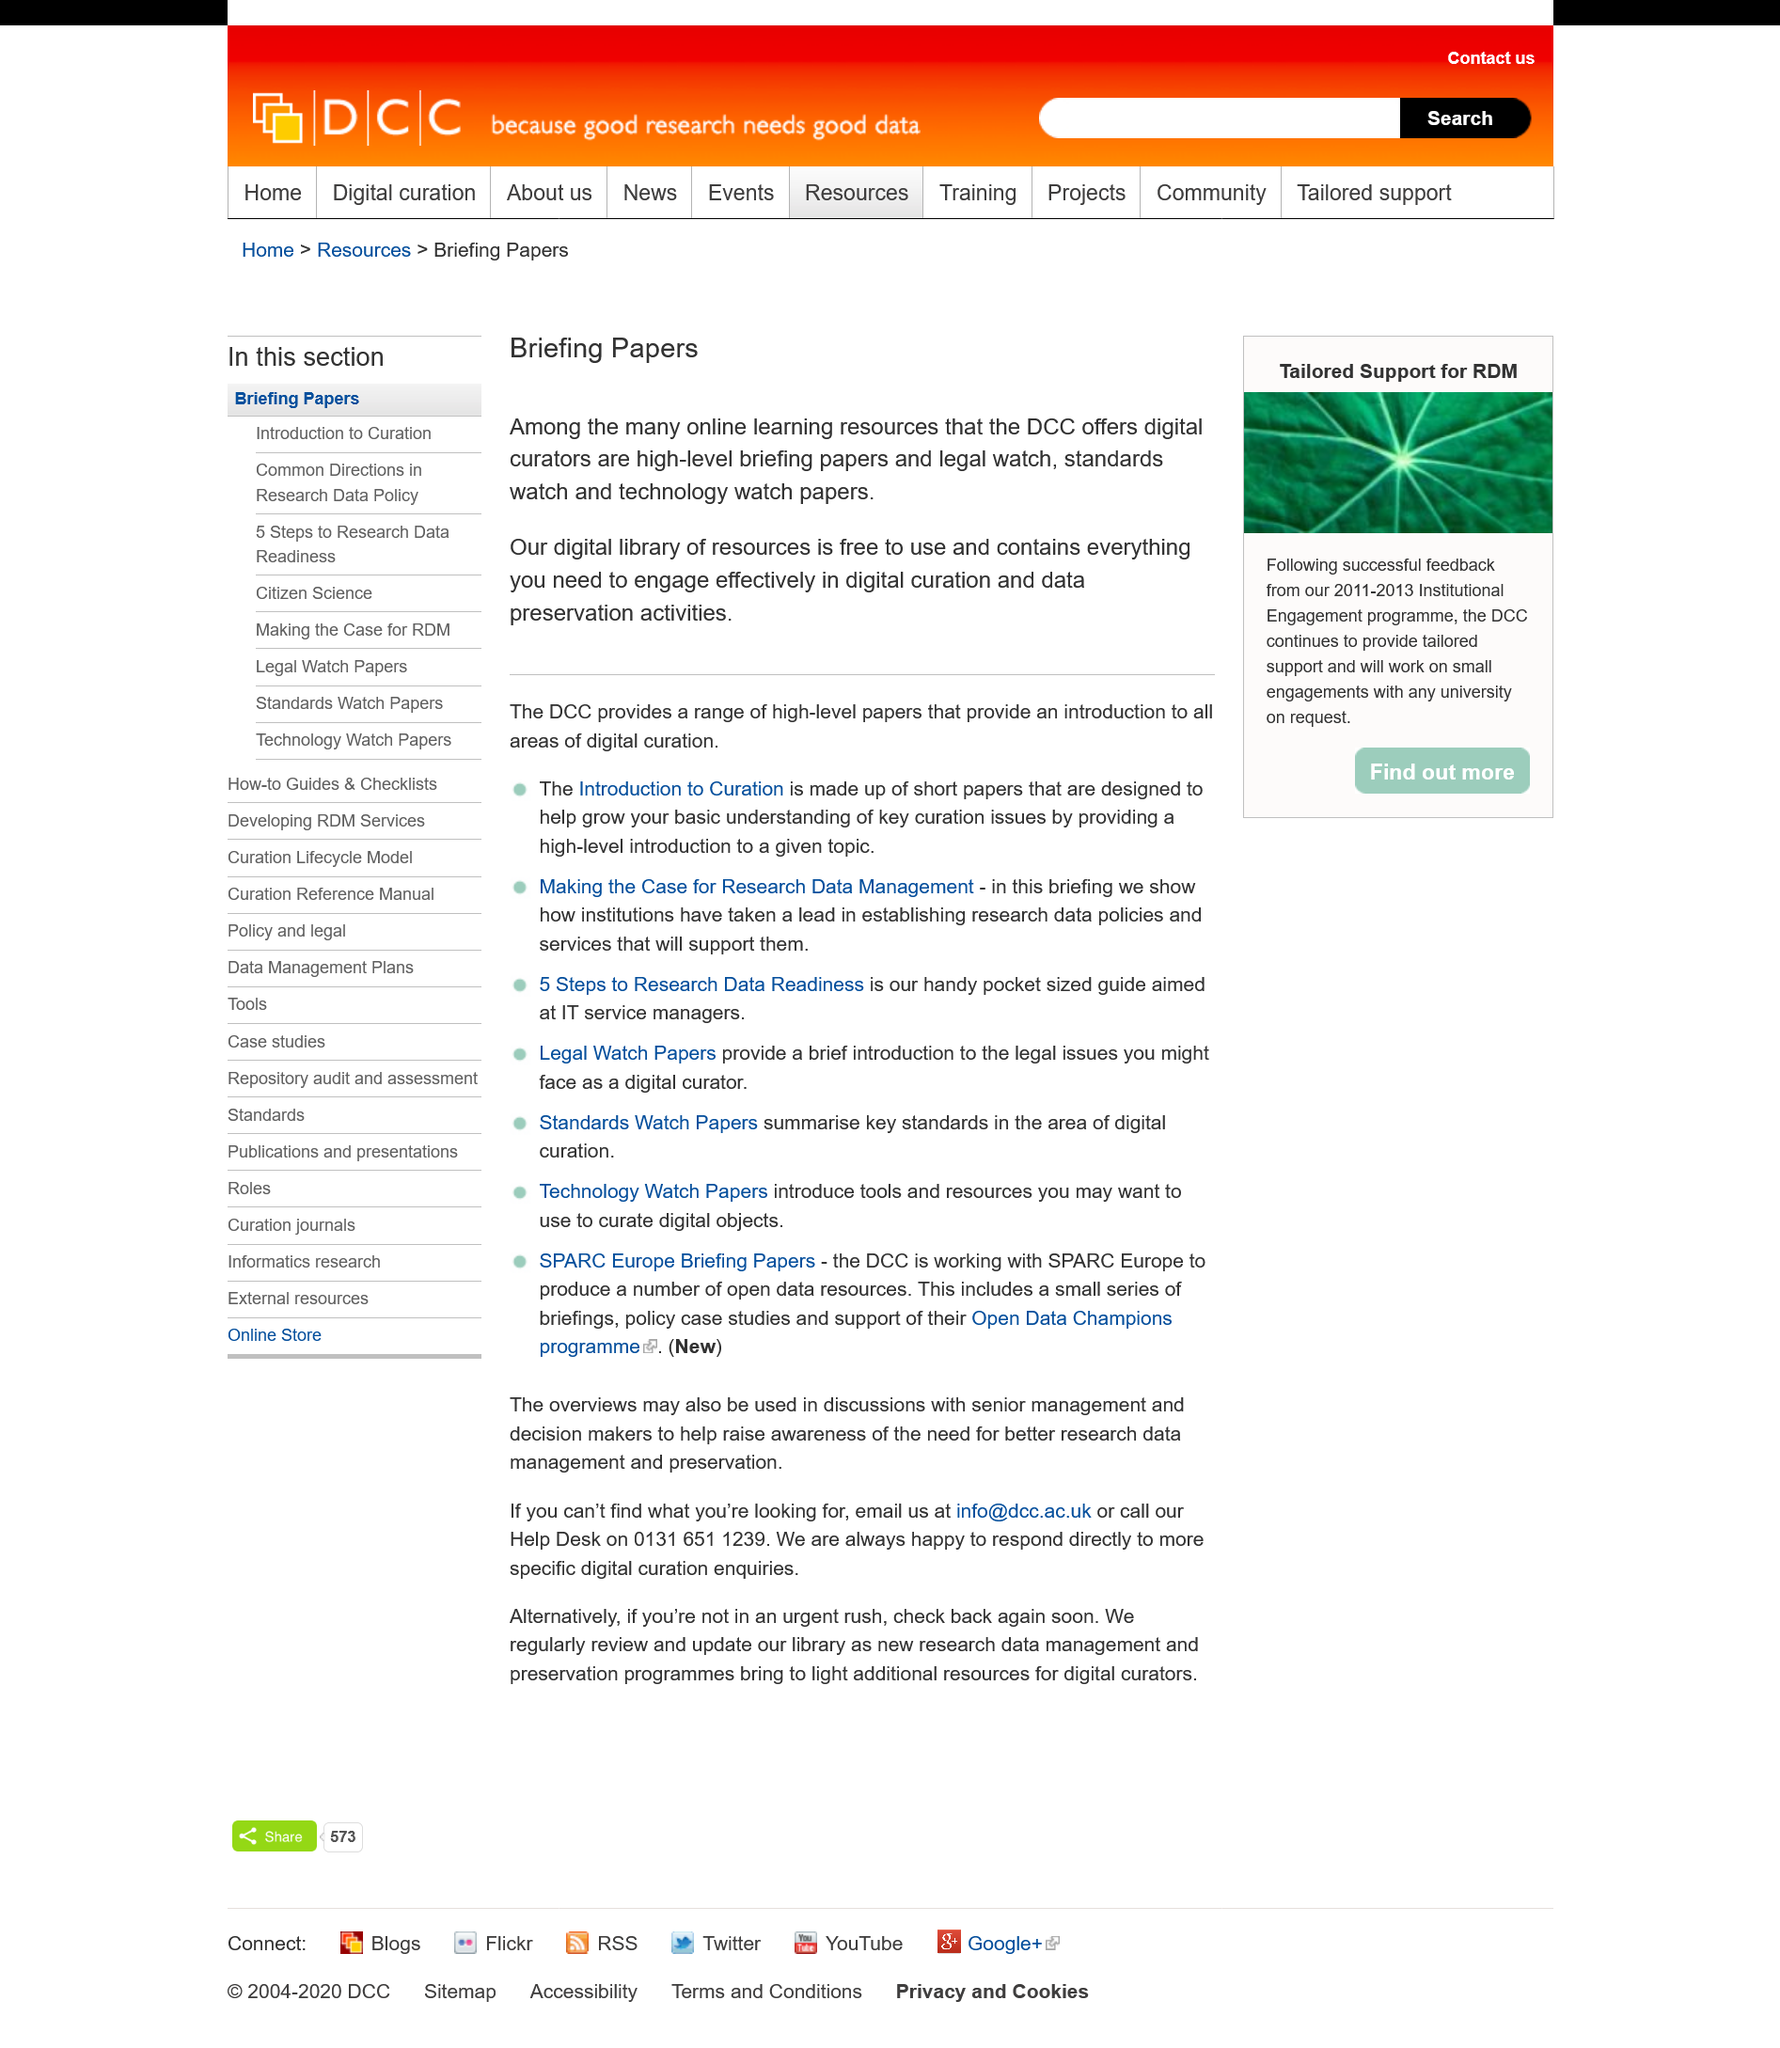List a handful of essential elements in this visual. It is free to use the digital library. The Distributed Computing Club offers a wide range of resources beyond online learning, including high-level briefing papers on various topics, Legal Watch, Standards Watch, and Technology Watch papers to keep members informed on the latest developments in the field. The digital library is a collection of resources necessary to perform digital curation and data preservation activities effectively in a digital environment. 